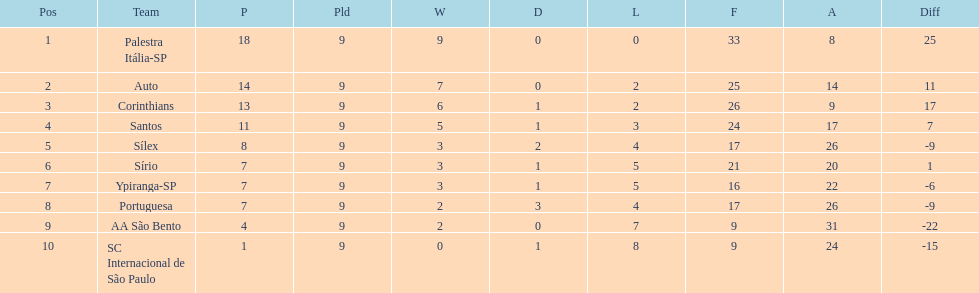Which team was the only team that was undefeated? Palestra Itália-SP. 